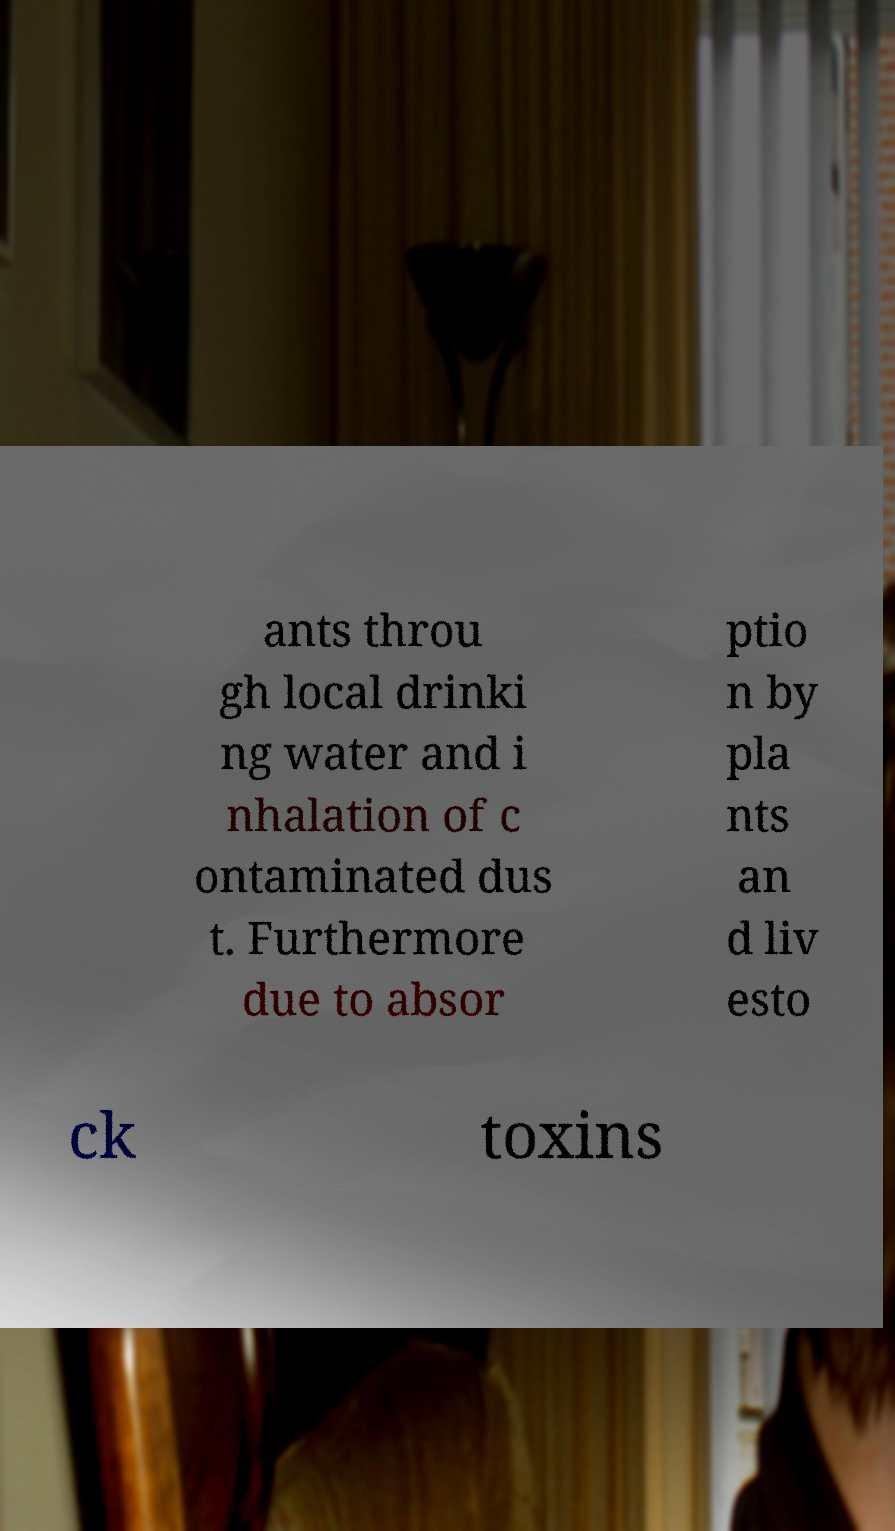Could you assist in decoding the text presented in this image and type it out clearly? ants throu gh local drinki ng water and i nhalation of c ontaminated dus t. Furthermore due to absor ptio n by pla nts an d liv esto ck toxins 